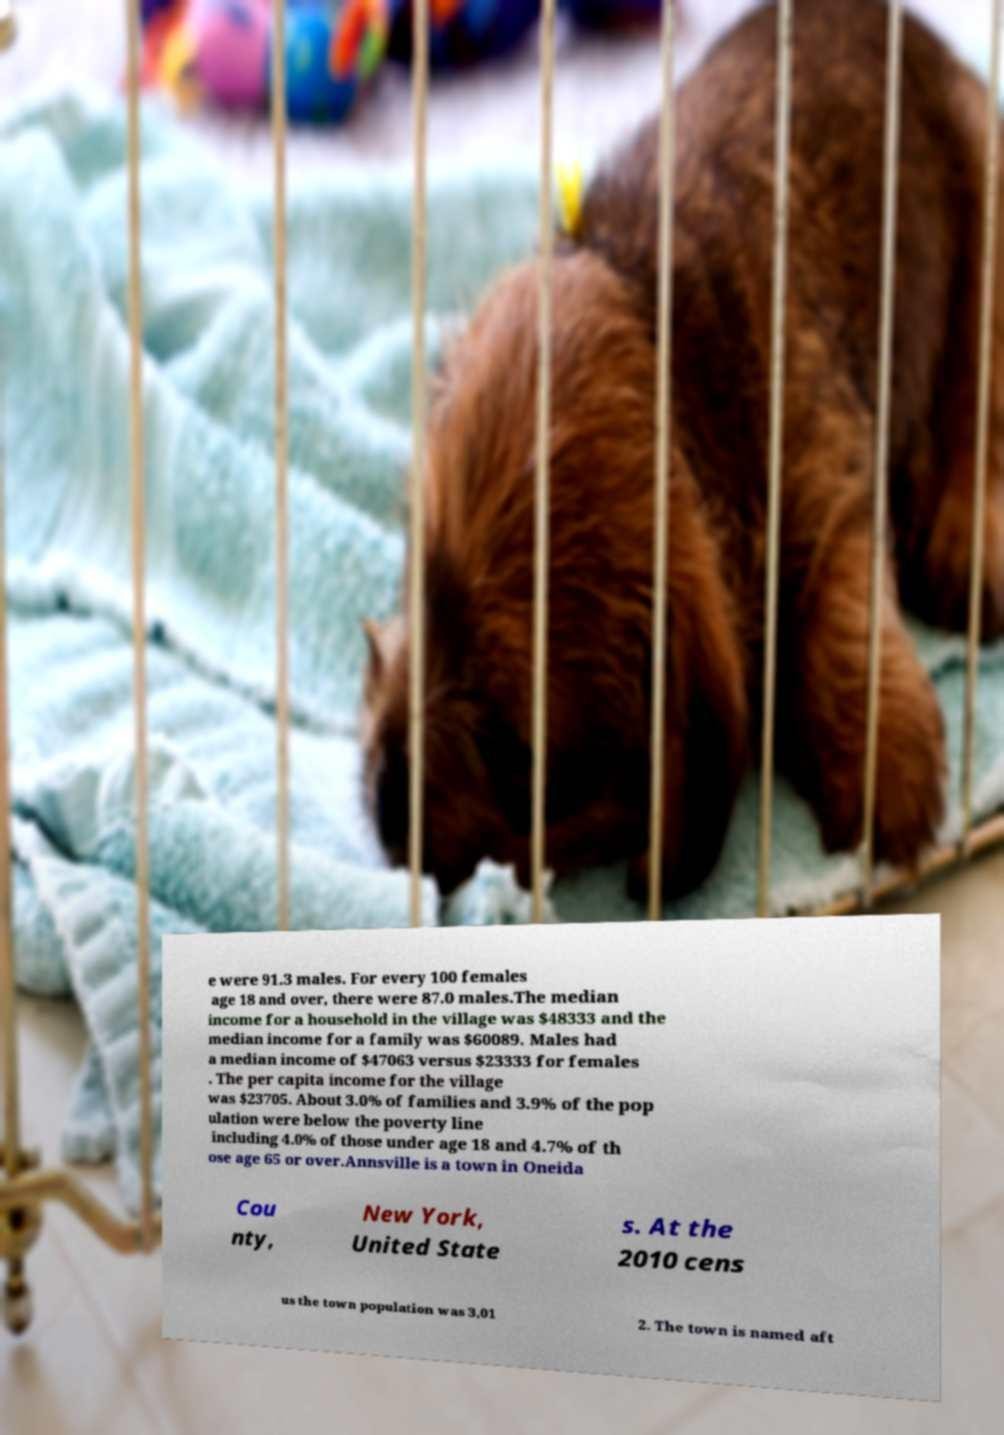I need the written content from this picture converted into text. Can you do that? e were 91.3 males. For every 100 females age 18 and over, there were 87.0 males.The median income for a household in the village was $48333 and the median income for a family was $60089. Males had a median income of $47063 versus $23333 for females . The per capita income for the village was $23705. About 3.0% of families and 3.9% of the pop ulation were below the poverty line including 4.0% of those under age 18 and 4.7% of th ose age 65 or over.Annsville is a town in Oneida Cou nty, New York, United State s. At the 2010 cens us the town population was 3,01 2. The town is named aft 